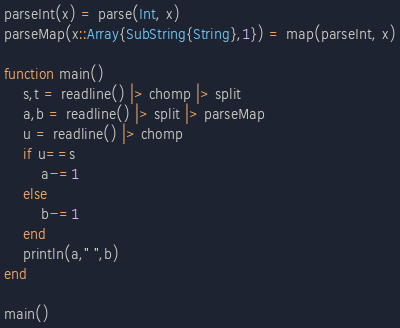Convert code to text. <code><loc_0><loc_0><loc_500><loc_500><_Julia_>parseInt(x) = parse(Int, x)
parseMap(x::Array{SubString{String},1}) = map(parseInt, x)

function main()
	s,t = readline() |> chomp |> split
	a,b = readline() |> split |> parseMap
	u = readline() |> chomp
	if u==s
		a-=1
	else
		b-=1
	end
	println(a," ",b)
end

main()</code> 